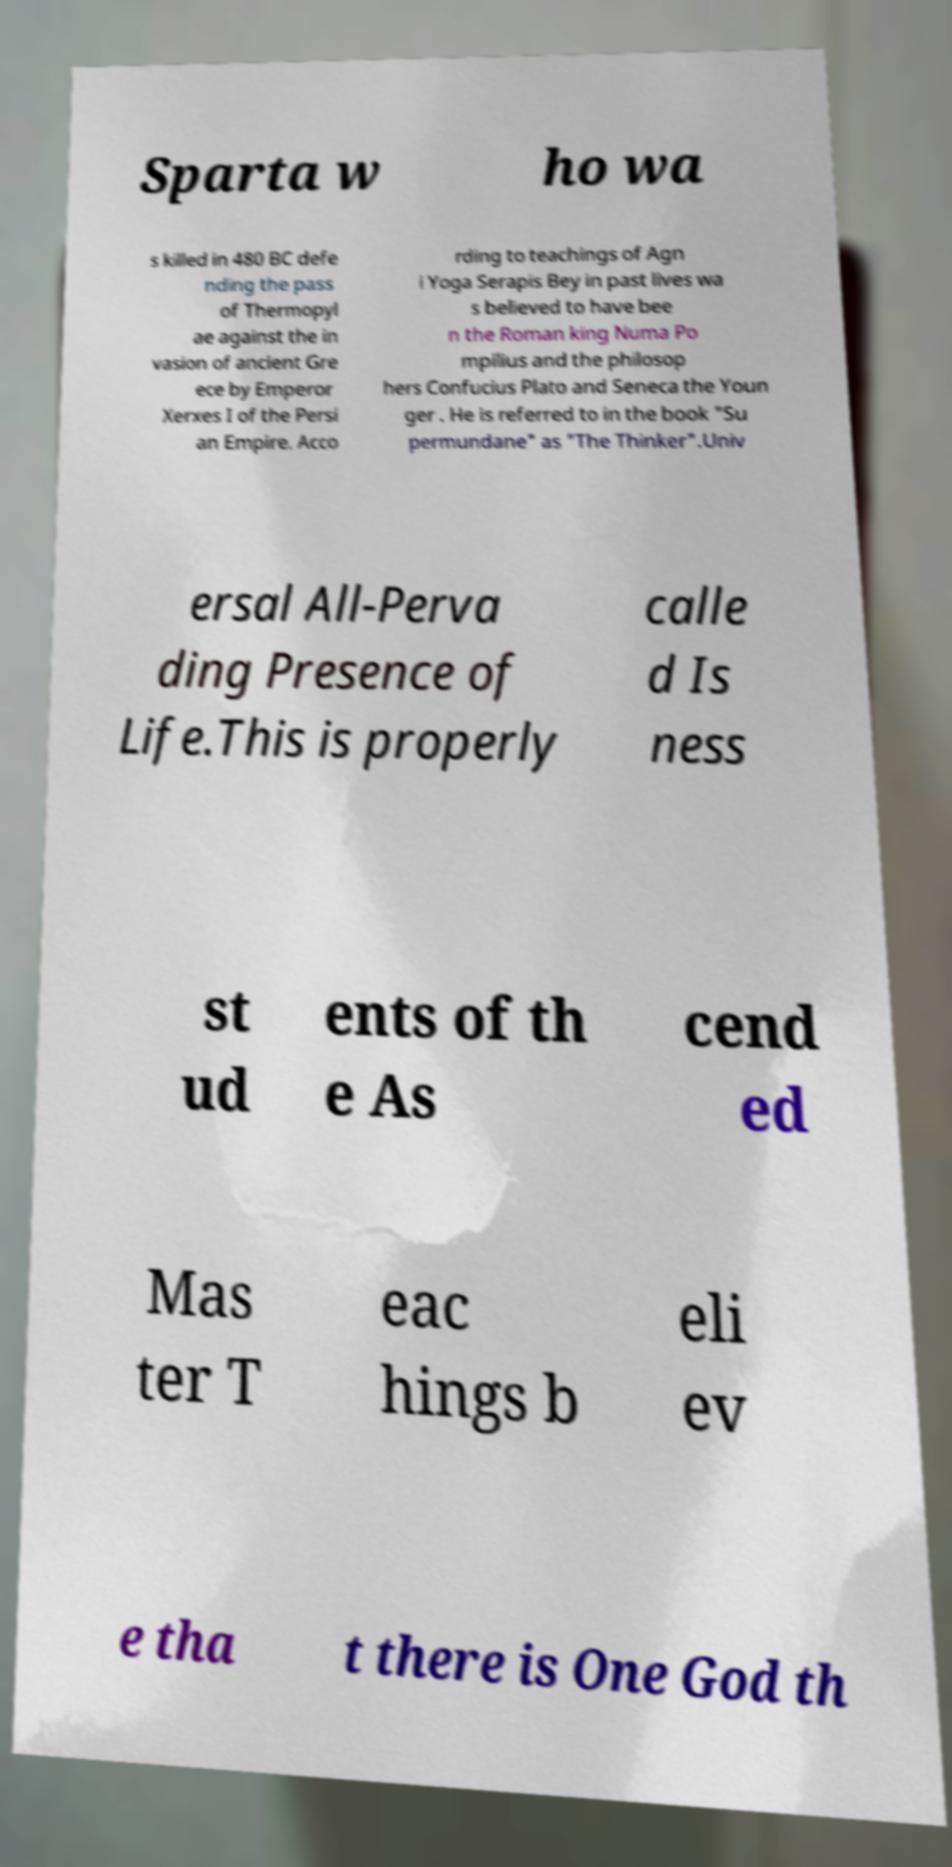There's text embedded in this image that I need extracted. Can you transcribe it verbatim? Sparta w ho wa s killed in 480 BC defe nding the pass of Thermopyl ae against the in vasion of ancient Gre ece by Emperor Xerxes I of the Persi an Empire. Acco rding to teachings of Agn i Yoga Serapis Bey in past lives wa s believed to have bee n the Roman king Numa Po mpilius and the philosop hers Confucius Plato and Seneca the Youn ger . He is referred to in the book "Su permundane" as "The Thinker".Univ ersal All-Perva ding Presence of Life.This is properly calle d Is ness st ud ents of th e As cend ed Mas ter T eac hings b eli ev e tha t there is One God th 